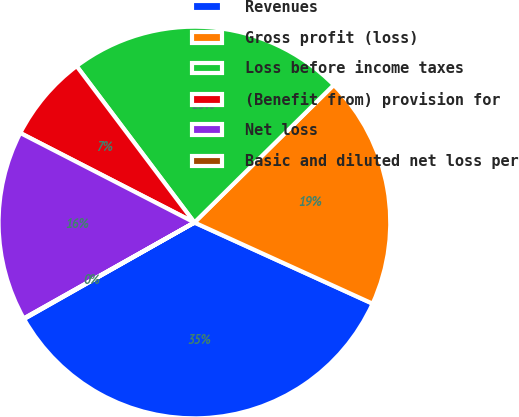<chart> <loc_0><loc_0><loc_500><loc_500><pie_chart><fcel>Revenues<fcel>Gross profit (loss)<fcel>Loss before income taxes<fcel>(Benefit from) provision for<fcel>Net loss<fcel>Basic and diluted net loss per<nl><fcel>35.0%<fcel>19.2%<fcel>22.88%<fcel>7.17%<fcel>15.71%<fcel>0.05%<nl></chart> 